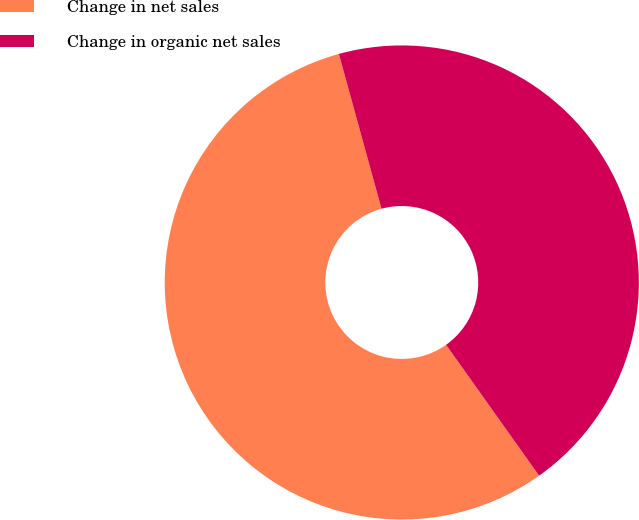Convert chart to OTSL. <chart><loc_0><loc_0><loc_500><loc_500><pie_chart><fcel>Change in net sales<fcel>Change in organic net sales<nl><fcel>55.56%<fcel>44.44%<nl></chart> 